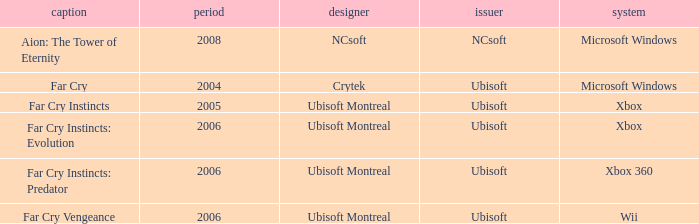Which publisher has Far Cry as the title? Ubisoft. 